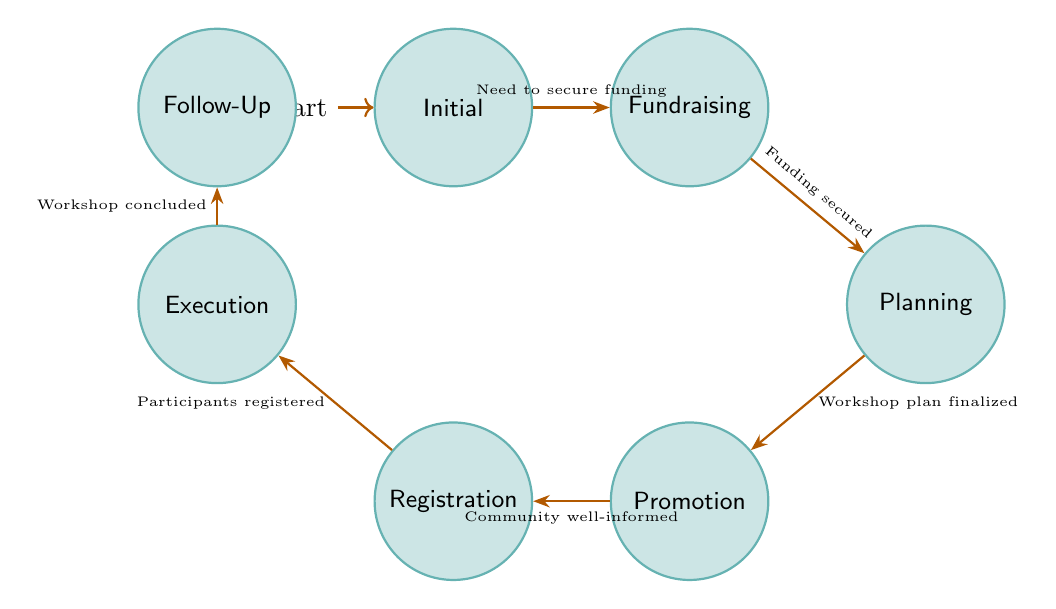What is the first state in the diagram? The first state is "Initial," which represents the starting point for planning the community workshop. This state is depicted at the leftmost position in the diagram.
Answer: Initial How many states are there in total? The diagram contains a total of seven states, each representing a different phase in the workshop process. They are visually represented as nodes.
Answer: 7 What is the condition to transition from "Fundraising" to "Planning"? The transition from "Fundraising" to "Planning" occurs when the condition "Funding secured" is met, indicating that the necessary financial resources have been obtained.
Answer: Funding secured Which state follows "Promotion"? The state that follows "Promotion" is "Registration," where participant sign-ups and inquiries are managed after the community has been informed about the workshop.
Answer: Registration What is the last state in the diagram? The last state in the diagram is "Follow-Up," which involves engaging with participants after the workshop for feedback and planning future initiatives.
Answer: Follow-Up What are the two direct transitions from "Execution"? The only direct transition from "Execution" is to "Follow-Up" upon the conclusion of the workshop, as indicated by the arrow pointing to the Follow-Up node.
Answer: Follow-Up What is the relationship between "Planning" and "Promotion"? The relationship between "Planning" and "Promotion" is that "Promotion" occurs after "Planning" has been finalized, signified by the transition that requires the workshop plan to be completed first.
Answer: Promotion Can "Registration" occur without "Promotion"? No, "Registration" cannot occur without "Promotion," as the transition to "Registration" depends on the community being well-informed about the workshop, which is the role of "Promotion."
Answer: No Which state comes before "Execution"? The state that comes before "Execution" is "Registration," as participants must be registered before the workshop can be conducted.
Answer: Registration 